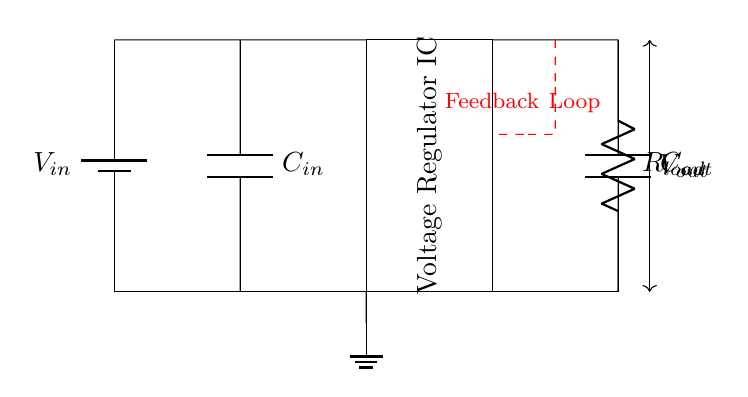What is the input voltage source labeled as? The input voltage source is labeled as Vin. This is the component providing power to the circuit.
Answer: Vin What type of component is shown at the center of the circuit? The component in the center is a Voltage Regulator IC. It regulates voltage to maintain a stable output.
Answer: Voltage Regulator IC What are the values of the input and output capacitors? The values are not specified in the diagram; however, the capacitors are labeled C_in and C_out. These are typically used for smoothing and stability.
Answer: C_in, C_out What could be the purpose of the feedback loop indicated in red? The feedback loop is used to monitor the output voltage and adjust the regulator's operation to maintain a stable output voltage despite changes in load or input voltage.
Answer: Stabilization What happens to the output voltage if the load resistor is increased? Increasing the load resistor generally leads to a reduction in load current, which can increase the output voltage if the regulator can respond accordingly. However, it may also depend on the regulator's specifications and conditions.
Answer: Potential increase How does the circuit maintain stable output voltage? The circuit maintains stable output voltage by using the feedback loop from the output to the voltage regulator. This feedback controls the resistance and ensures a steady voltage level at the output.
Answer: Feedback control 